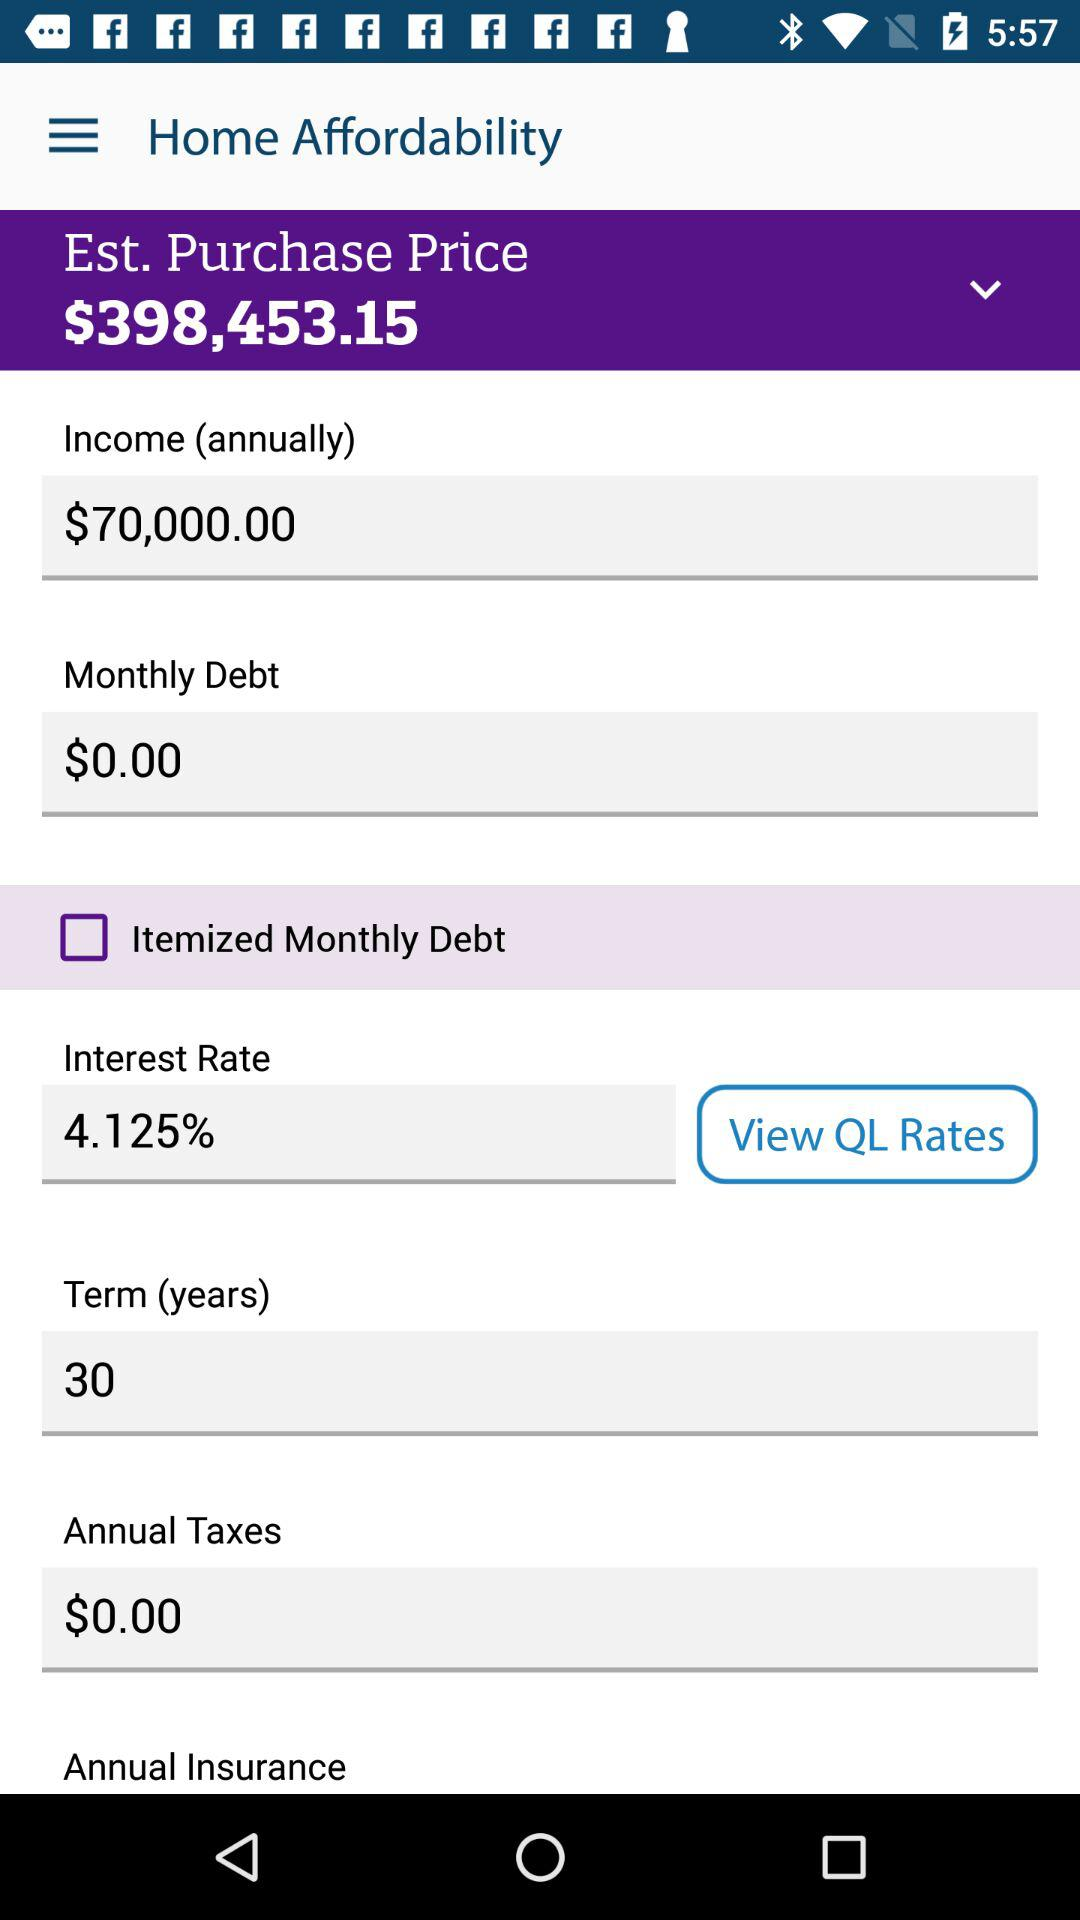What is the status of the itemized monthly debt? The status is off. 